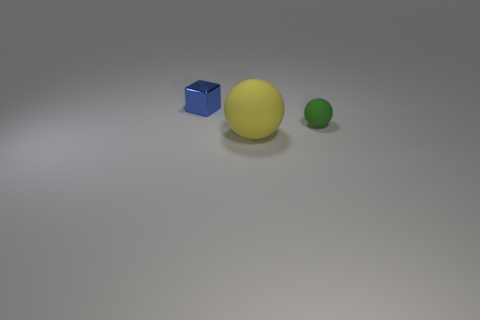What is the material of the tiny blue thing?
Your response must be concise. Metal. What number of objects are either big purple metallic cylinders or balls?
Provide a short and direct response. 2. What is the size of the thing that is in front of the green thing?
Make the answer very short. Large. How many other objects are there of the same material as the yellow sphere?
Your answer should be very brief. 1. Are there any small blue blocks behind the small object in front of the tiny cube?
Provide a succinct answer. Yes. Is there anything else that has the same shape as the blue shiny object?
Keep it short and to the point. No. What color is the tiny matte object that is the same shape as the large thing?
Your answer should be very brief. Green. How big is the block?
Provide a succinct answer. Small. Are there fewer green matte things that are to the left of the small ball than small rubber cylinders?
Provide a short and direct response. No. Do the yellow object and the thing that is behind the small ball have the same material?
Offer a very short reply. No. 